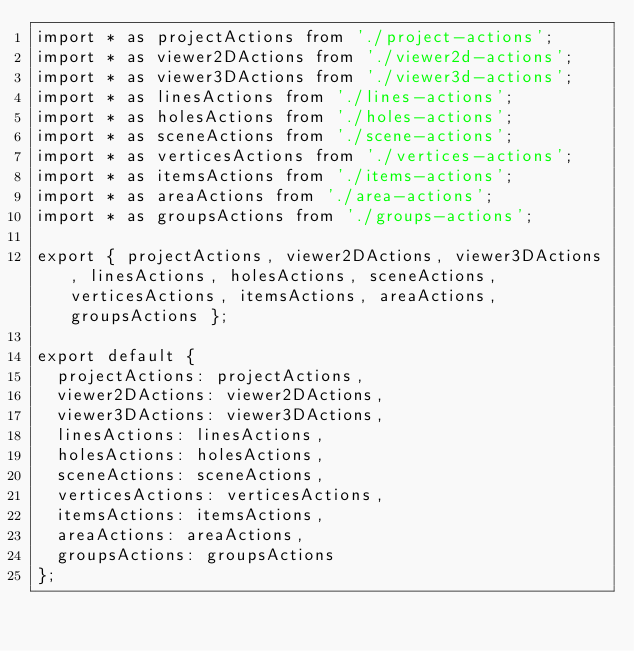<code> <loc_0><loc_0><loc_500><loc_500><_JavaScript_>import * as projectActions from './project-actions';
import * as viewer2DActions from './viewer2d-actions';
import * as viewer3DActions from './viewer3d-actions';
import * as linesActions from './lines-actions';
import * as holesActions from './holes-actions';
import * as sceneActions from './scene-actions';
import * as verticesActions from './vertices-actions';
import * as itemsActions from './items-actions';
import * as areaActions from './area-actions';
import * as groupsActions from './groups-actions';

export { projectActions, viewer2DActions, viewer3DActions, linesActions, holesActions, sceneActions, verticesActions, itemsActions, areaActions, groupsActions };

export default {
  projectActions: projectActions,
  viewer2DActions: viewer2DActions,
  viewer3DActions: viewer3DActions,
  linesActions: linesActions,
  holesActions: holesActions,
  sceneActions: sceneActions,
  verticesActions: verticesActions,
  itemsActions: itemsActions,
  areaActions: areaActions,
  groupsActions: groupsActions
};</code> 